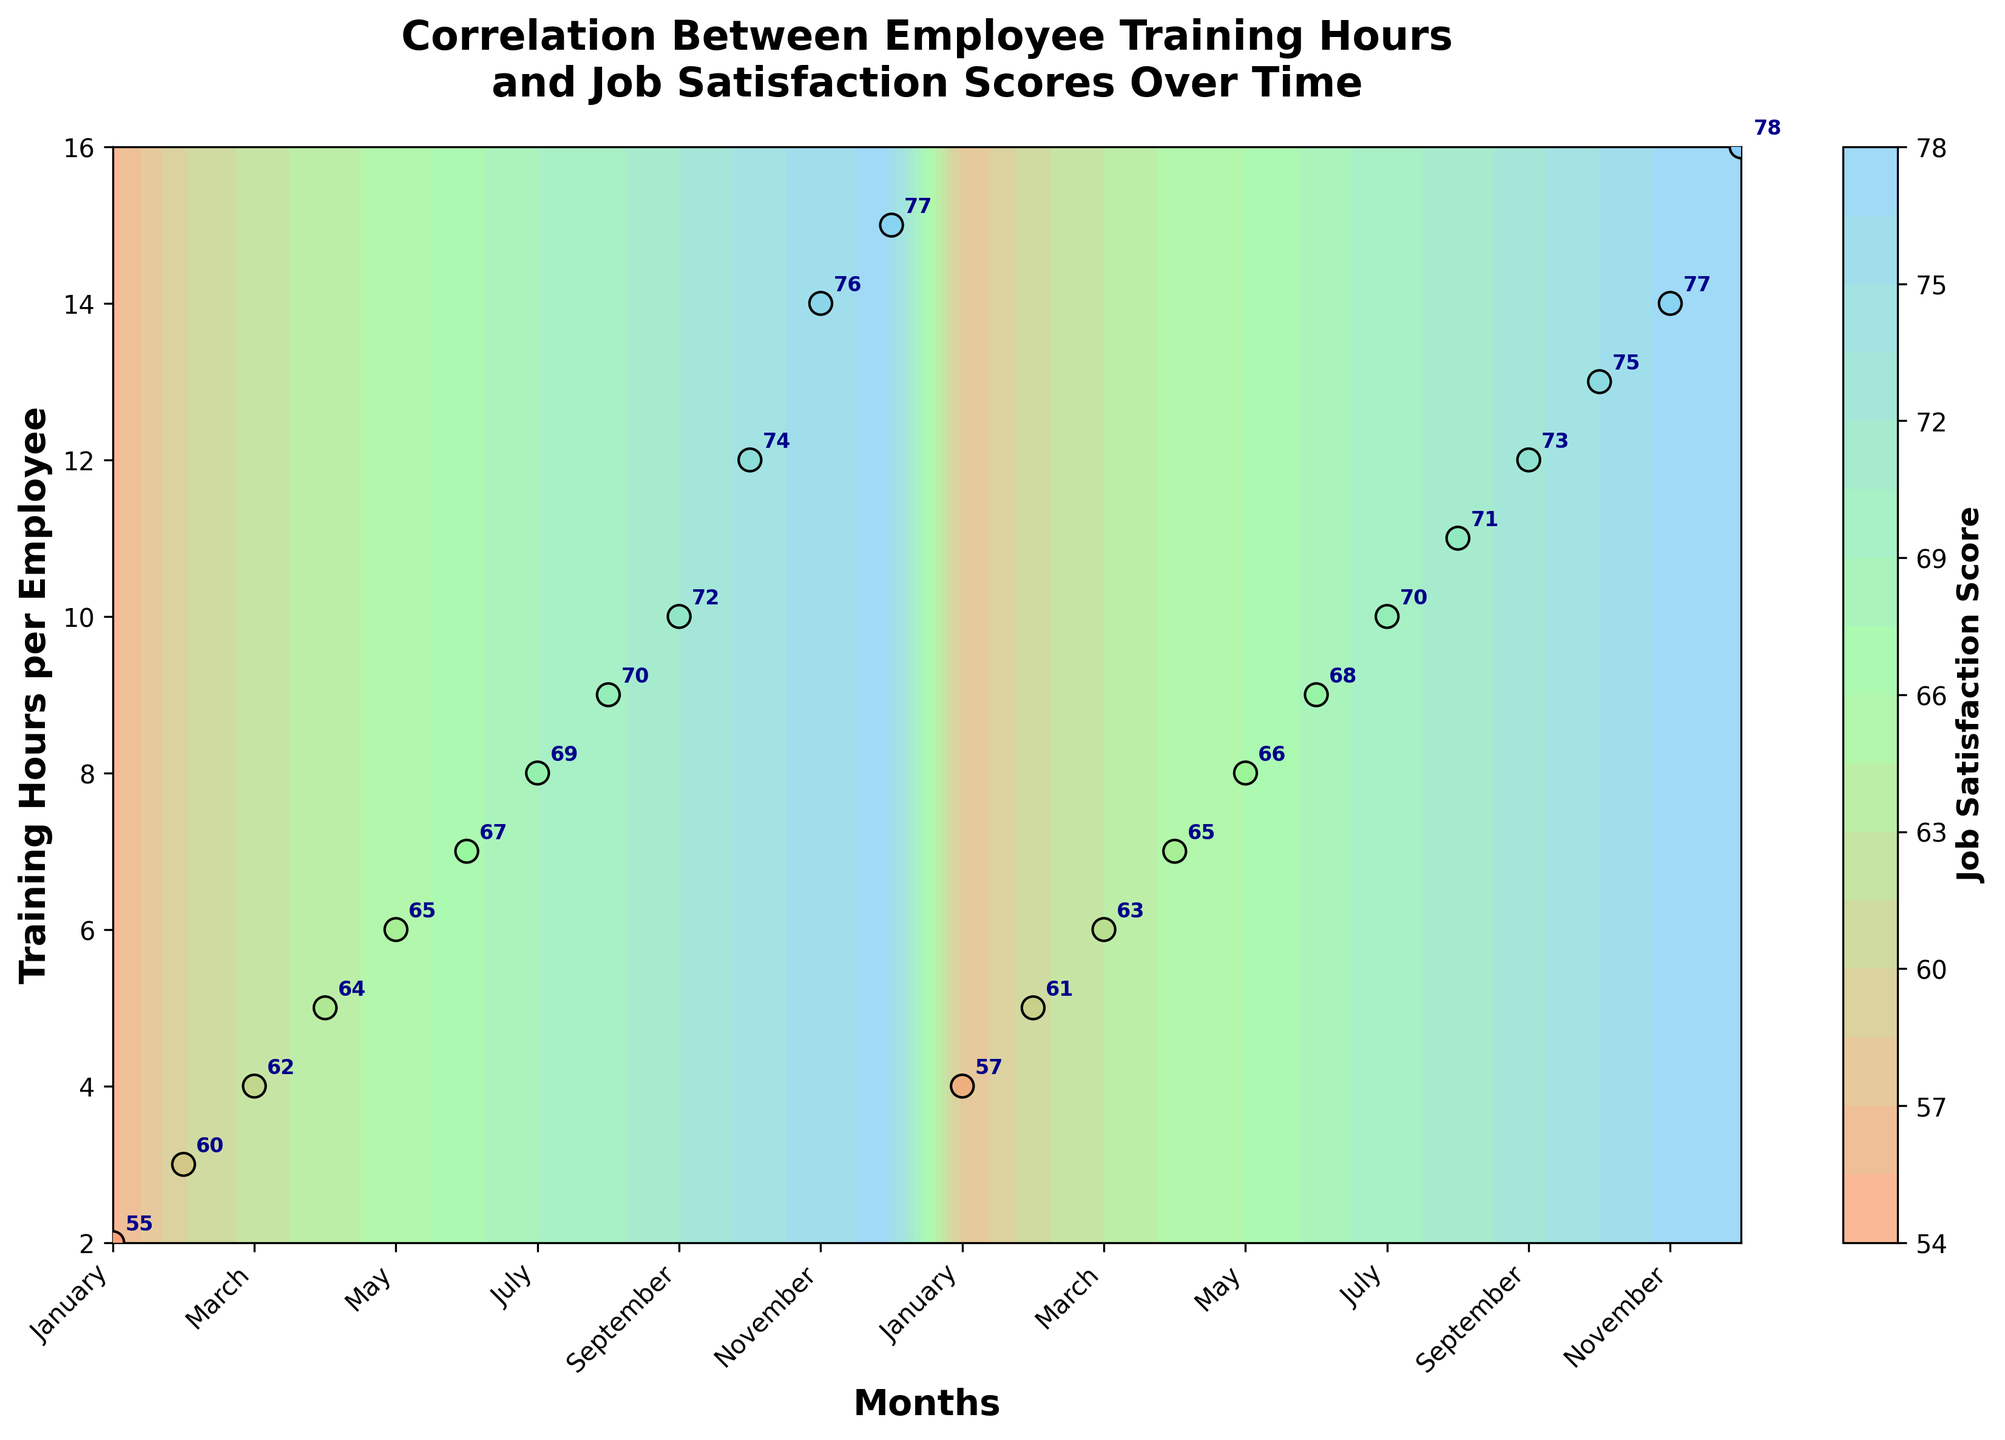What's the title of the figure? The title is displayed at the top of the figure. It usually conveys the main topic or key insight of the figure. In this case, it is about the correlation between employee training hours and job satisfaction scores over time.
Answer: Correlation Between Employee Training Hours and Job Satisfaction Scores Over Time How many months are represented in the figure? The months can be counted based on the x-axis labels. They range from January to December for two years, which total 24 months.
Answer: 24 Which month shows the highest job satisfaction score? To find the month with the highest job satisfaction score, look at the scatter plot points and their annotations. December of the second year has the highest score of 78.
Answer: December of the second year How does job satisfaction score change as training hours increase from 2 to 15 hours in the first year? By tracing the scatter plot points and observing their annotations, one can see that the job satisfaction score increases roughly steadily from 55 to 77 as training hours increase from 2 to 15 in the first year.
Answer: Increases from 55 to 77 What is the general trend of job satisfaction scores relative to training hours? By examining the color gradient in the contour plot and the scatter points, the general trend indicates that job satisfaction scores tend to increase as training hours per employee increase.
Answer: Increase Comparing May of the first year and May of the second year, which has a higher job satisfaction score? Locate the scatter points for May in both years and compare their annotations. May of the second year has a job satisfaction score of 66, while the first year's May score is 65.
Answer: May of the second year What is the average job satisfaction score for the months with 10 training hours per employee? First identify the months with 10 training hours (July of the first year and September of the second year). The scores are 69 and 73, respectively. Averaging these scores, (69 + 73) / 2 = 71.
Answer: 71 How is the color map used in this figure? The color map ranges from light shades to darker shades, representing lower to higher job satisfaction scores, respectively, making it easier to visualize the score gradient.
Answer: To indicate job satisfaction levels Are there any months where the training hours are the same but job satisfaction scores are different? By analyzing each pair of months with the same training hours on the scatter plot, we find that November has different scores for the same number of training hours (76 and 77).
Answer: Yes 